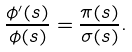<formula> <loc_0><loc_0><loc_500><loc_500>\frac { \phi ^ { \prime } ( s ) } { \phi ( s ) } = \frac { \pi ( s ) } { \sigma ( s ) } .</formula> 